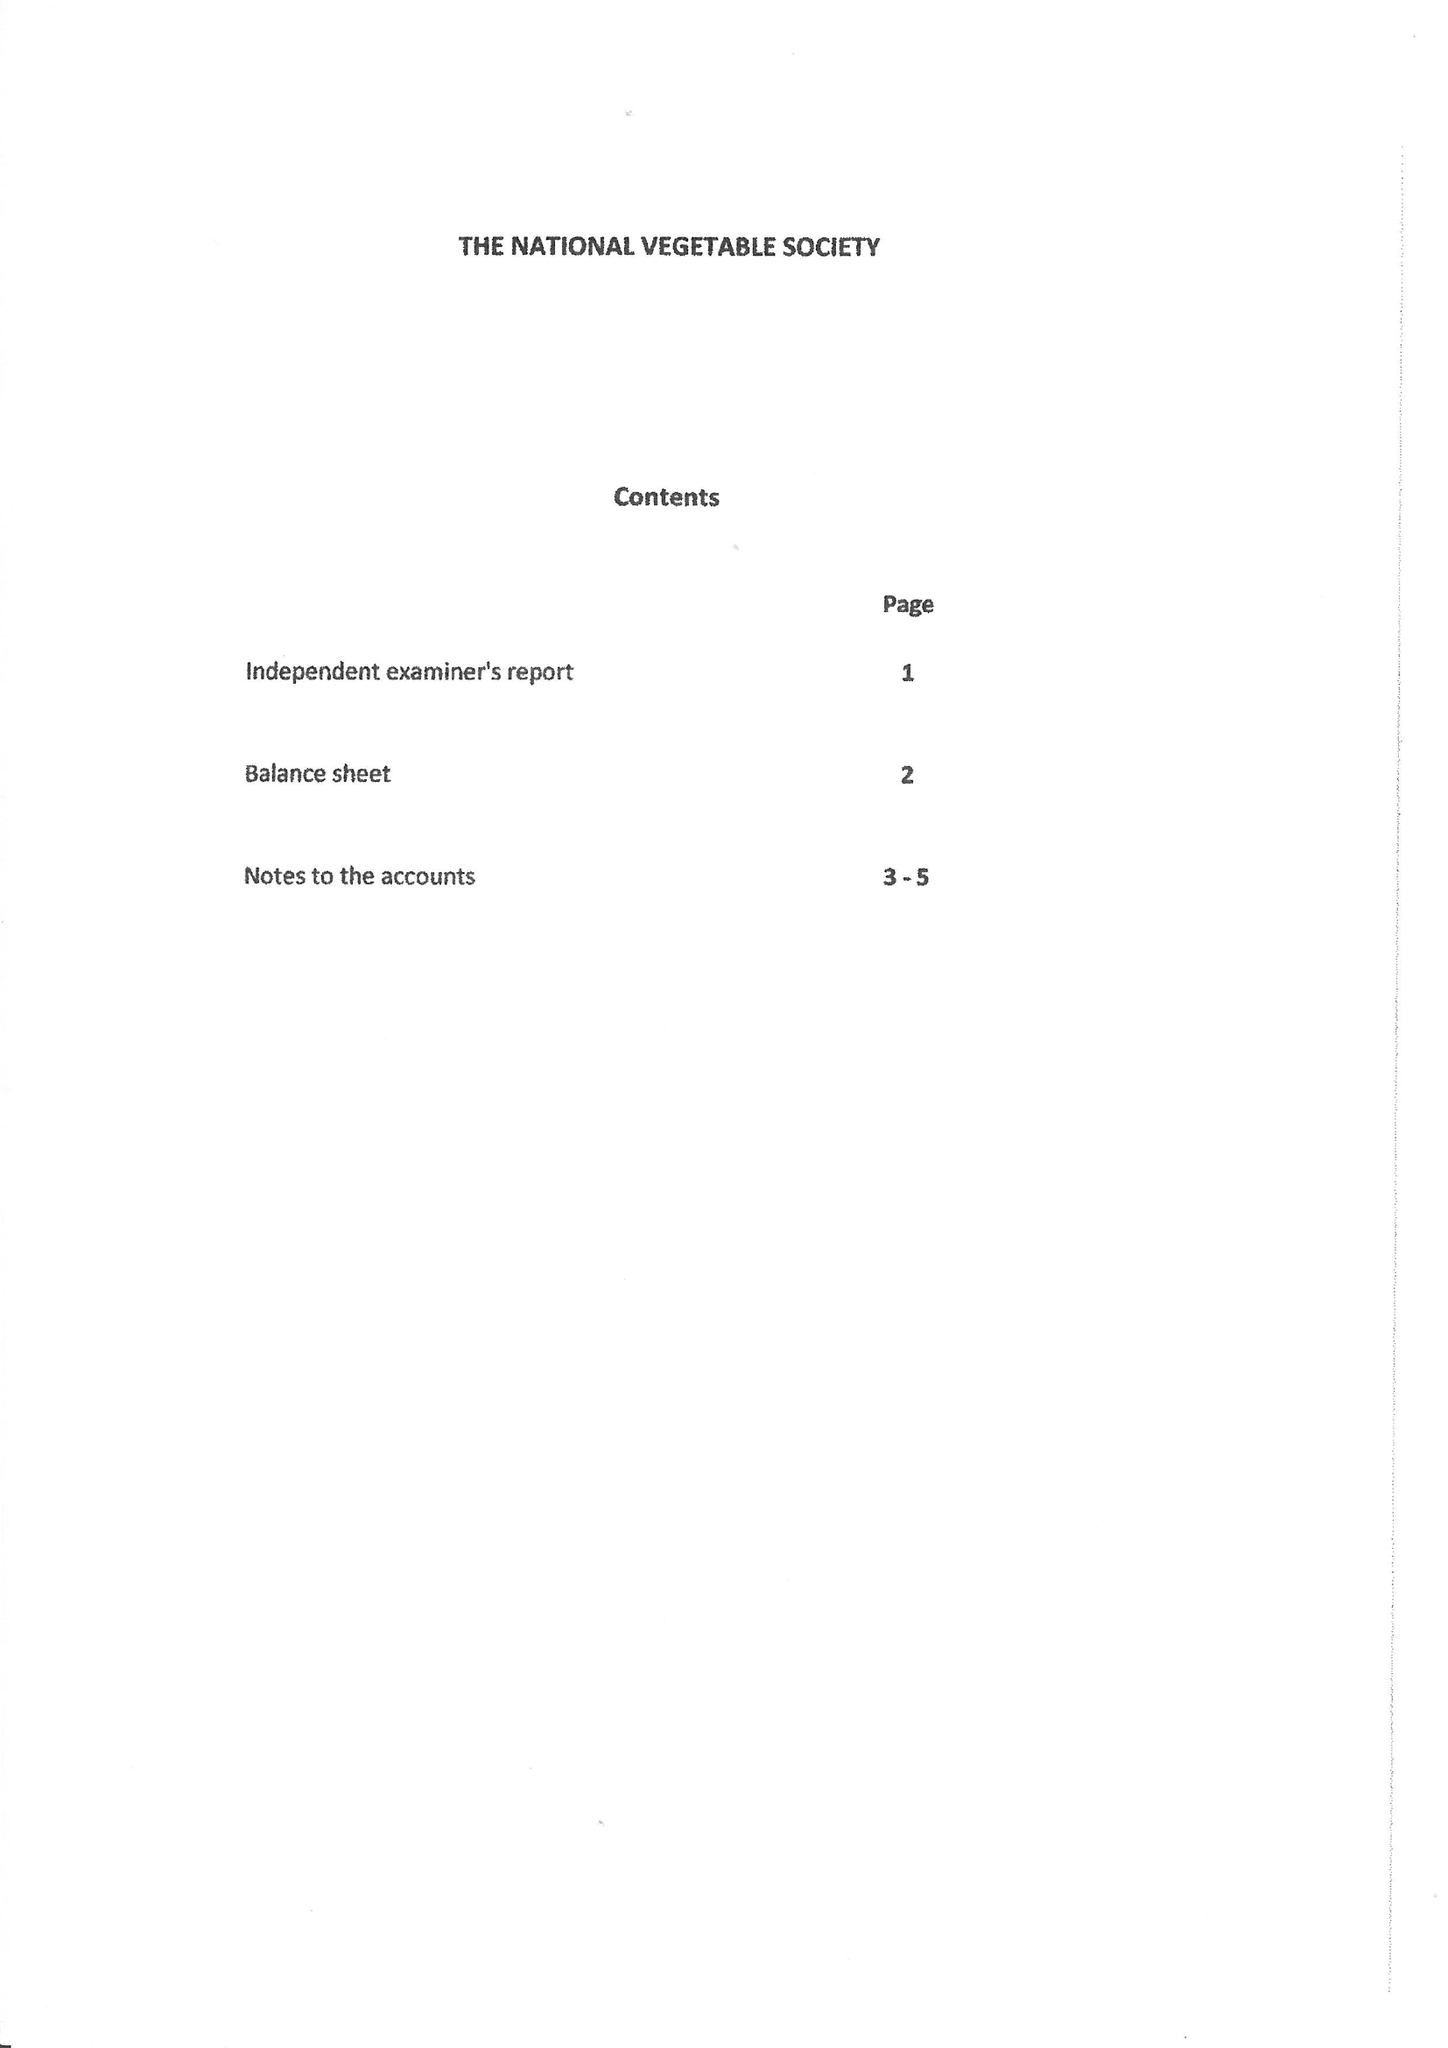What is the value for the address__postcode?
Answer the question using a single word or phrase. KY3 9RH 